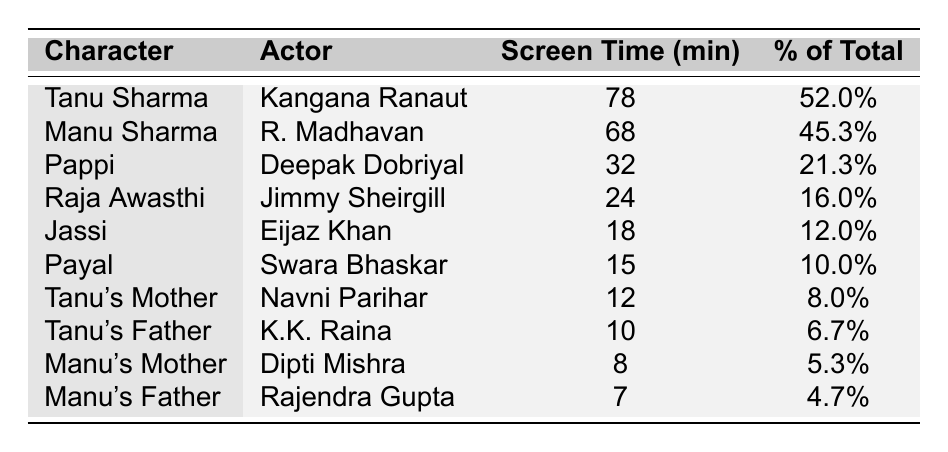What is the total screen time for all main characters listed? To find the total screen time, we sum up the screen time of all the characters: 78 + 68 + 32 + 24 + 18 + 15 + 12 + 10 + 8 + 7 = 302 minutes.
Answer: 302 minutes Which character has the highest screen time? Tanu Sharma has the highest screen time of 78 minutes, being the leading character.
Answer: Tanu Sharma What percentage of the total screen time does Manu Sharma have? Manu Sharma has a screen time of 68 minutes, which is 45.3% of the total screen time (as explicitly mentioned in the table).
Answer: 45.3% Which character has both name and screen time greater than 20 minutes? Characters with screen time greater than 20 minutes include Tanu Sharma (78), Manu Sharma (68), Pappi (32), and Raja Awasthi (24).
Answer: Tanu Sharma, Manu Sharma, Pappi, Raja Awasthi Is Pappi's screen time more than Jassi's? Pappi has 32 minutes while Jassi has only 18 minutes of screen time. Thus, Pappi's screen time is greater than that of Jassi.
Answer: Yes How much screen time does Tanu's Father have compared to Manu's Mother? Tanu's Father has 10 minutes and Manu's Mother has 8 minutes; 10 - 8 = 2 minutes more for Tanu's Father.
Answer: 2 minutes more What is the average screen time of all the characters listed? The total screen time is 302 minutes and there are 10 characters. Thus, the average is 302 / 10 = 30.2 minutes.
Answer: 30.2 minutes Who are the characters with the least screen time, and what is their screen time? The characters with the least screen time are Manu's Father at 7 minutes and Manu's Mother at 8 minutes.
Answer: Manu's Father (7 minutes), Manu's Mother (8 minutes) If we exclude Tanu Sharma's screen time, what percentage does Manu Sharma represent? After excluding Tanu Sharma's 78 minutes, the remaining screen time is 302 - 78 = 224 minutes; Manu's 68 minutes becomes (68/224) * 100% = approximately 30.4%.
Answer: 30.4% Which actor plays the character with the second highest screen time? The second highest screen time belongs to Manu Sharma, portrayed by R. Madhavan.
Answer: R. Madhavan 